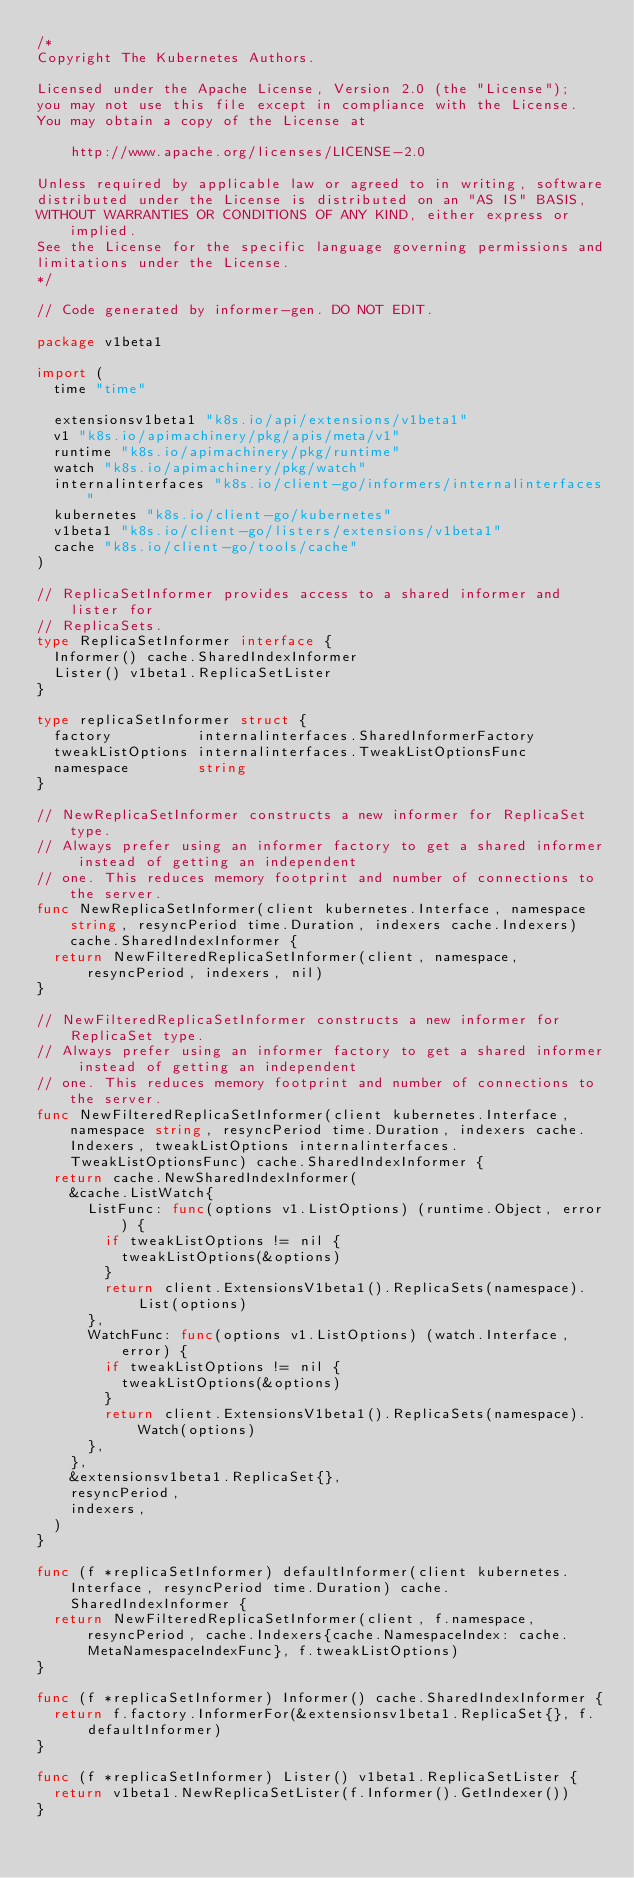Convert code to text. <code><loc_0><loc_0><loc_500><loc_500><_Go_>/*
Copyright The Kubernetes Authors.

Licensed under the Apache License, Version 2.0 (the "License");
you may not use this file except in compliance with the License.
You may obtain a copy of the License at

    http://www.apache.org/licenses/LICENSE-2.0

Unless required by applicable law or agreed to in writing, software
distributed under the License is distributed on an "AS IS" BASIS,
WITHOUT WARRANTIES OR CONDITIONS OF ANY KIND, either express or implied.
See the License for the specific language governing permissions and
limitations under the License.
*/

// Code generated by informer-gen. DO NOT EDIT.

package v1beta1

import (
	time "time"

	extensionsv1beta1 "k8s.io/api/extensions/v1beta1"
	v1 "k8s.io/apimachinery/pkg/apis/meta/v1"
	runtime "k8s.io/apimachinery/pkg/runtime"
	watch "k8s.io/apimachinery/pkg/watch"
	internalinterfaces "k8s.io/client-go/informers/internalinterfaces"
	kubernetes "k8s.io/client-go/kubernetes"
	v1beta1 "k8s.io/client-go/listers/extensions/v1beta1"
	cache "k8s.io/client-go/tools/cache"
)

// ReplicaSetInformer provides access to a shared informer and lister for
// ReplicaSets.
type ReplicaSetInformer interface {
	Informer() cache.SharedIndexInformer
	Lister() v1beta1.ReplicaSetLister
}

type replicaSetInformer struct {
	factory          internalinterfaces.SharedInformerFactory
	tweakListOptions internalinterfaces.TweakListOptionsFunc
	namespace        string
}

// NewReplicaSetInformer constructs a new informer for ReplicaSet type.
// Always prefer using an informer factory to get a shared informer instead of getting an independent
// one. This reduces memory footprint and number of connections to the server.
func NewReplicaSetInformer(client kubernetes.Interface, namespace string, resyncPeriod time.Duration, indexers cache.Indexers) cache.SharedIndexInformer {
	return NewFilteredReplicaSetInformer(client, namespace, resyncPeriod, indexers, nil)
}

// NewFilteredReplicaSetInformer constructs a new informer for ReplicaSet type.
// Always prefer using an informer factory to get a shared informer instead of getting an independent
// one. This reduces memory footprint and number of connections to the server.
func NewFilteredReplicaSetInformer(client kubernetes.Interface, namespace string, resyncPeriod time.Duration, indexers cache.Indexers, tweakListOptions internalinterfaces.TweakListOptionsFunc) cache.SharedIndexInformer {
	return cache.NewSharedIndexInformer(
		&cache.ListWatch{
			ListFunc: func(options v1.ListOptions) (runtime.Object, error) {
				if tweakListOptions != nil {
					tweakListOptions(&options)
				}
				return client.ExtensionsV1beta1().ReplicaSets(namespace).List(options)
			},
			WatchFunc: func(options v1.ListOptions) (watch.Interface, error) {
				if tweakListOptions != nil {
					tweakListOptions(&options)
				}
				return client.ExtensionsV1beta1().ReplicaSets(namespace).Watch(options)
			},
		},
		&extensionsv1beta1.ReplicaSet{},
		resyncPeriod,
		indexers,
	)
}

func (f *replicaSetInformer) defaultInformer(client kubernetes.Interface, resyncPeriod time.Duration) cache.SharedIndexInformer {
	return NewFilteredReplicaSetInformer(client, f.namespace, resyncPeriod, cache.Indexers{cache.NamespaceIndex: cache.MetaNamespaceIndexFunc}, f.tweakListOptions)
}

func (f *replicaSetInformer) Informer() cache.SharedIndexInformer {
	return f.factory.InformerFor(&extensionsv1beta1.ReplicaSet{}, f.defaultInformer)
}

func (f *replicaSetInformer) Lister() v1beta1.ReplicaSetLister {
	return v1beta1.NewReplicaSetLister(f.Informer().GetIndexer())
}
</code> 